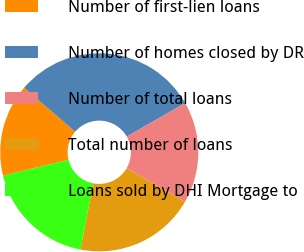<chart> <loc_0><loc_0><loc_500><loc_500><pie_chart><fcel>Number of first-lien loans<fcel>Number of homes closed by DR<fcel>Number of total loans<fcel>Total number of loans<fcel>Loans sold by DHI Mortgage to<nl><fcel>15.09%<fcel>30.44%<fcel>16.62%<fcel>19.69%<fcel>18.16%<nl></chart> 